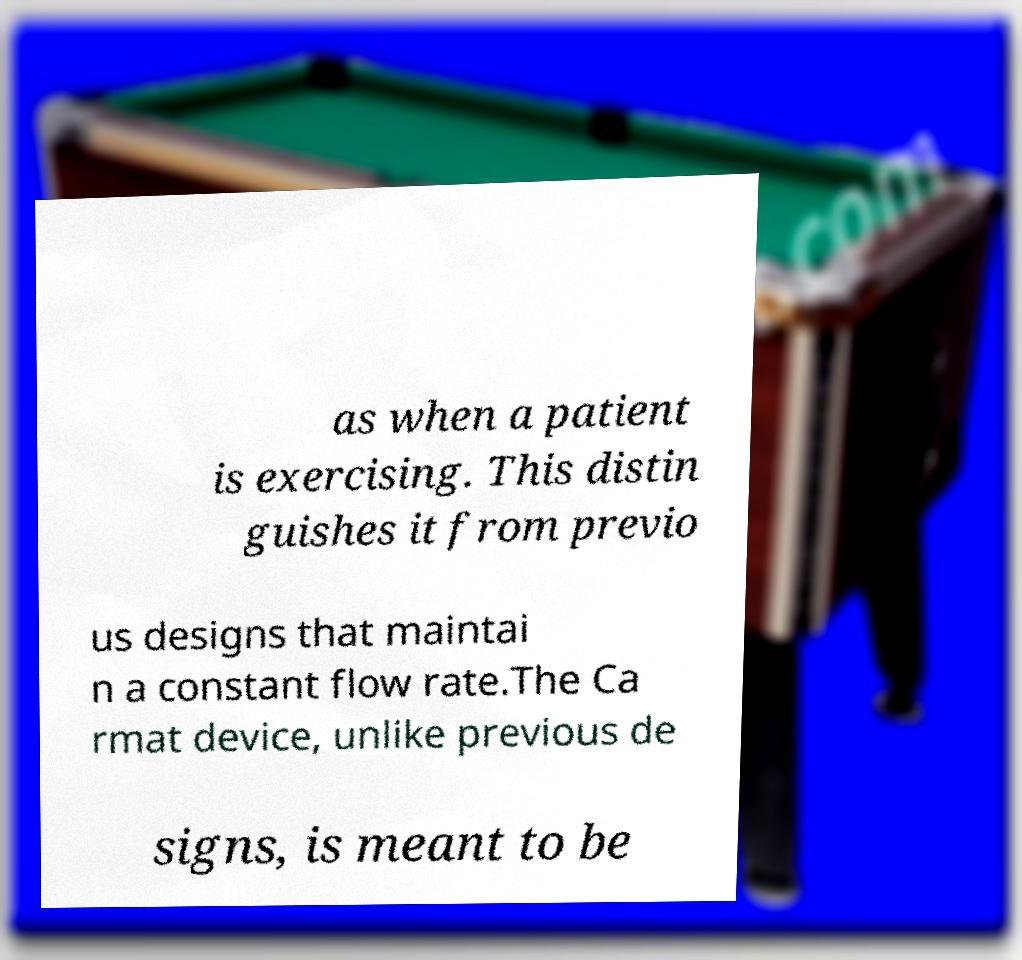There's text embedded in this image that I need extracted. Can you transcribe it verbatim? as when a patient is exercising. This distin guishes it from previo us designs that maintai n a constant flow rate.The Ca rmat device, unlike previous de signs, is meant to be 